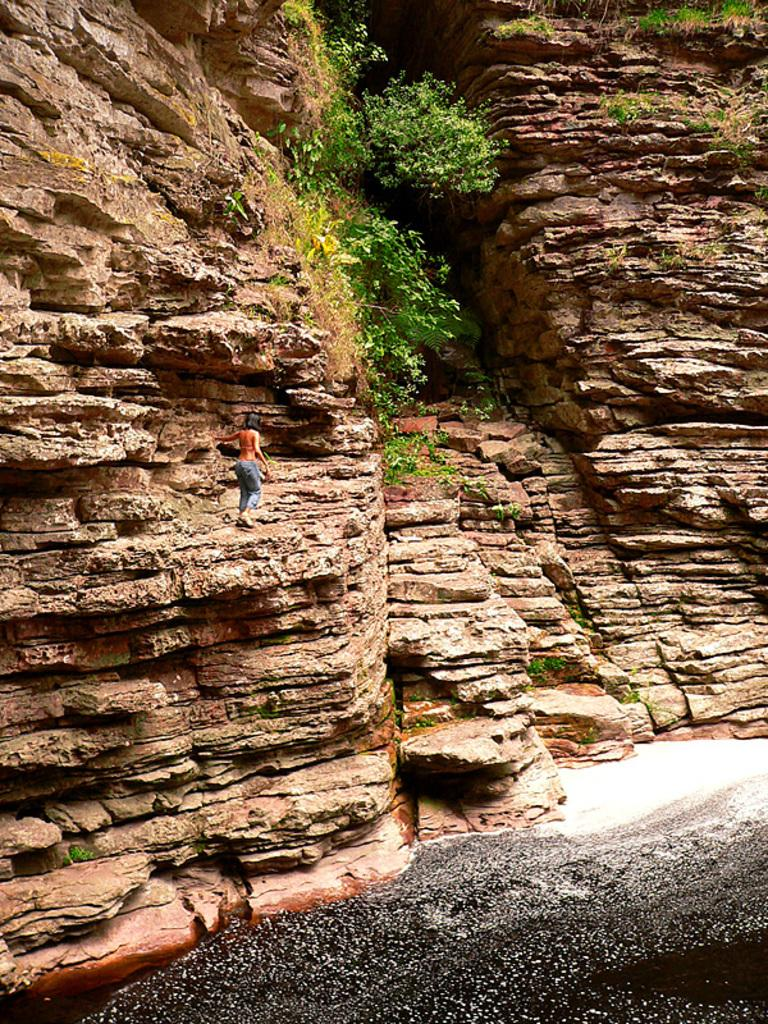What geographical feature is present in the image? There is a hill in the image. Is there anyone on the hill? Yes, there is a person on the hill. What else can be seen in the image besides the hill and the person? There are plants visible in the image. What type of bun is the person holding in the image? There is no bun present in the image; the person is standing on a hill with plants visible nearby. 